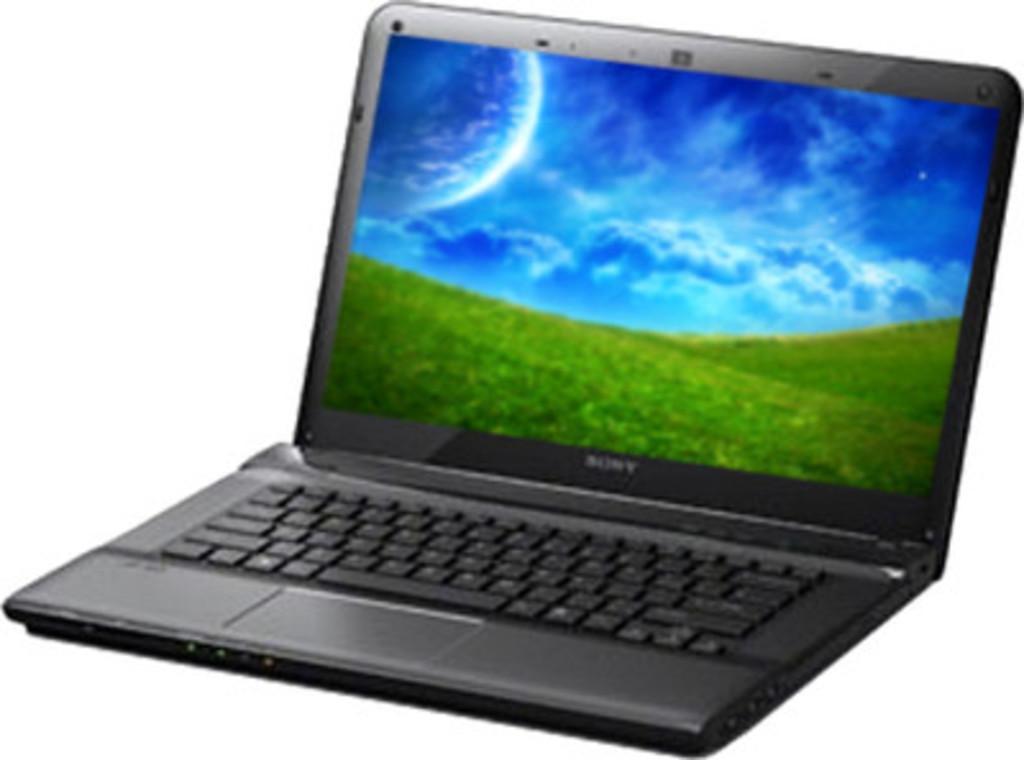What brand of laptop is this?
Offer a very short reply. Sony. 